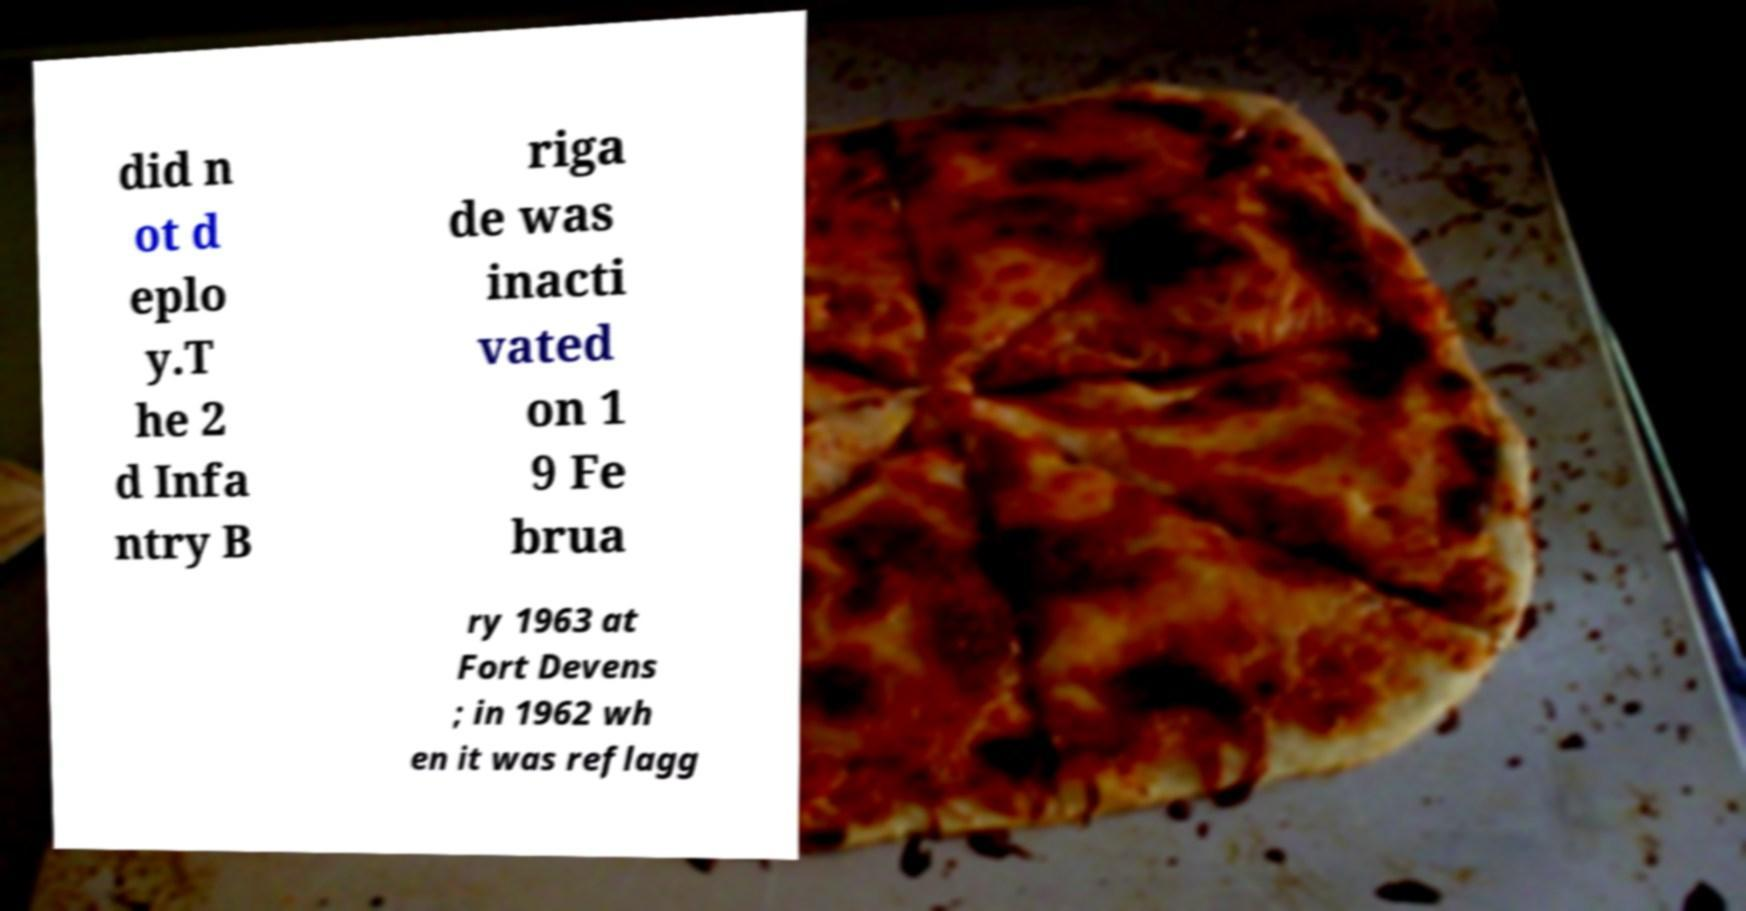Could you assist in decoding the text presented in this image and type it out clearly? did n ot d eplo y.T he 2 d Infa ntry B riga de was inacti vated on 1 9 Fe brua ry 1963 at Fort Devens ; in 1962 wh en it was reflagg 